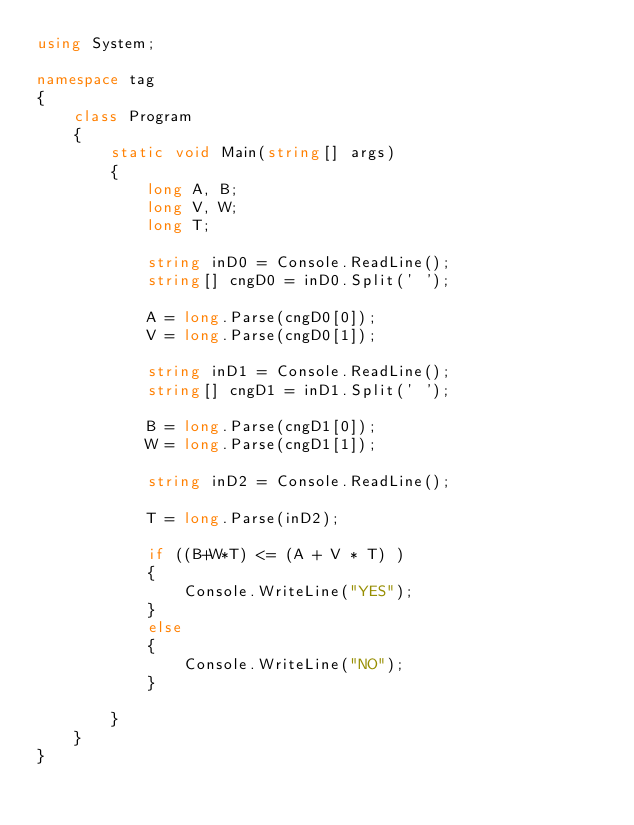<code> <loc_0><loc_0><loc_500><loc_500><_C#_>using System;

namespace tag
{
    class Program
    {
        static void Main(string[] args)
        {
            long A, B;
            long V, W;
            long T;

            string inD0 = Console.ReadLine();
            string[] cngD0 = inD0.Split(' ');

            A = long.Parse(cngD0[0]);
            V = long.Parse(cngD0[1]);

            string inD1 = Console.ReadLine();
            string[] cngD1 = inD1.Split(' ');

            B = long.Parse(cngD1[0]);
            W = long.Parse(cngD1[1]);

            string inD2 = Console.ReadLine();

            T = long.Parse(inD2);

            if ((B+W*T) <= (A + V * T) )
            {
                Console.WriteLine("YES");
            }
            else
            {
                Console.WriteLine("NO");
            }

        }
    }
}
</code> 